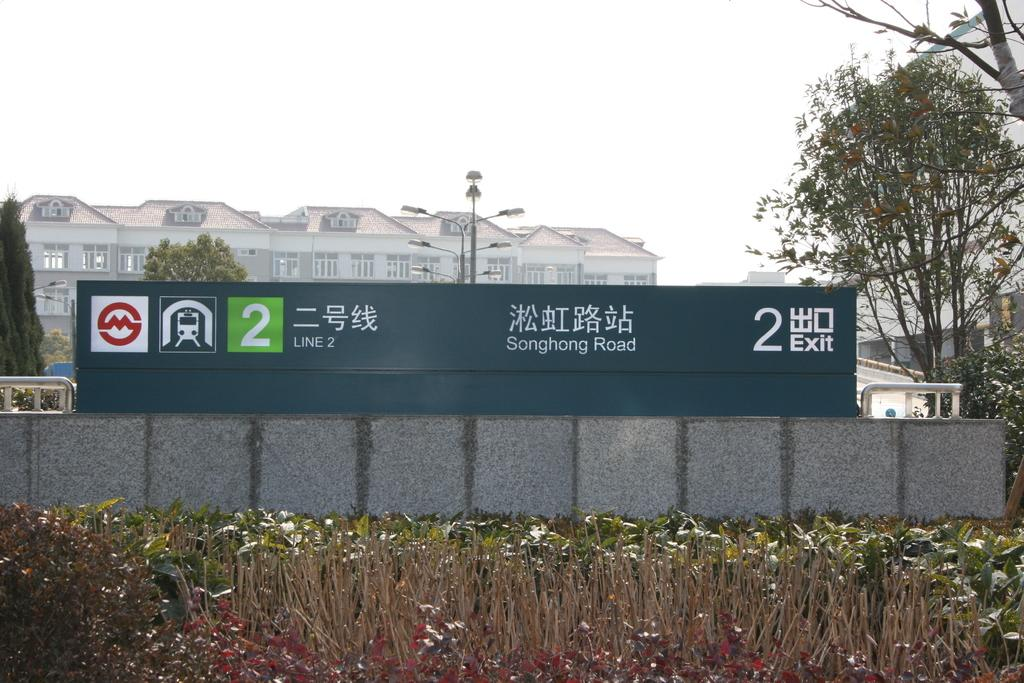What type of structure can be seen in the image? There is a fencing wall in the image. What other elements are present in the image besides the fencing wall? There are plants, trees, street lights, other objects, buildings in the background, and the sky visible in the background. Can you describe the vegetation in the image? There are plants and trees in the image. What type of lighting is present in the image? There are street lights in the image. How many grapes are hanging from the fencing wall in the image? There are no grapes present in the image. What level of experience does the beginner have with the fencing wall in the image? There is no indication of any person's experience level with the fencing wall in the image. 